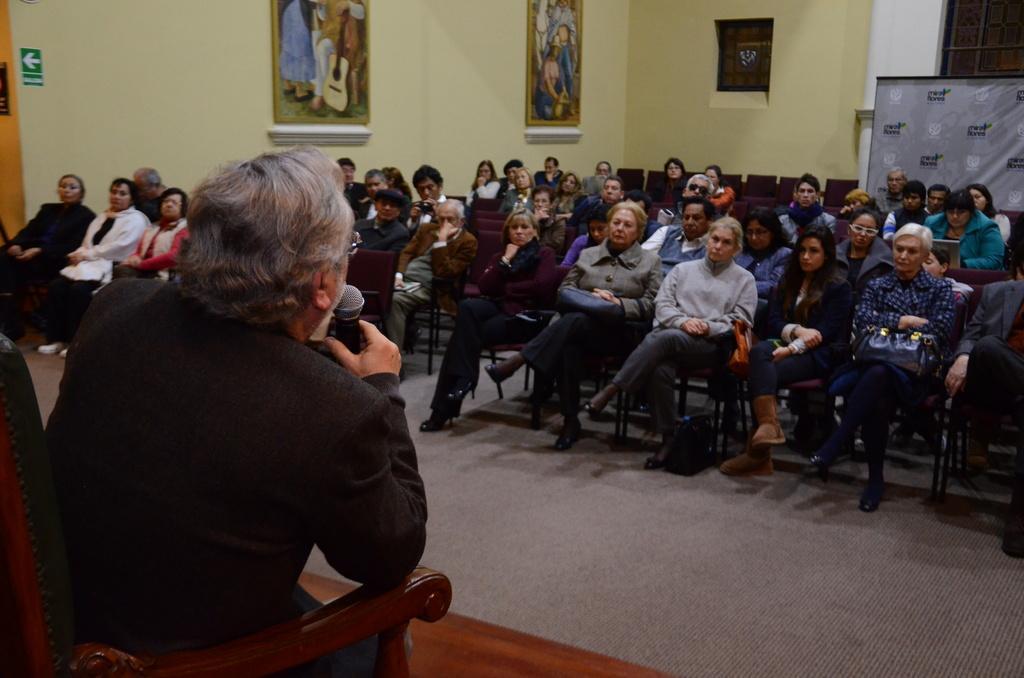Could you give a brief overview of what you see in this image? In the image we can see there is a man sitting on the chair and he is holding a mic in his hand. In front of him there are other people sitting on the chairs and there are photo frames on the wall. 